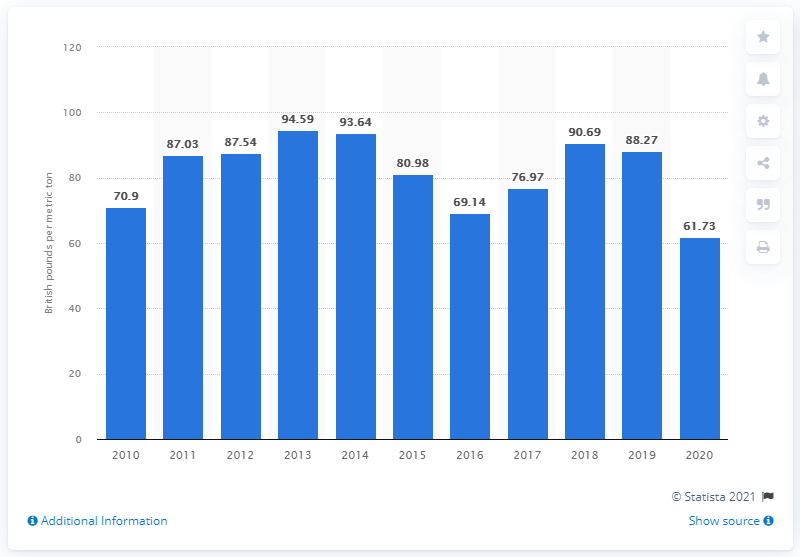List a handful of essential elements in this visual. In 2020, the average price of coal per metric ton in the UK was 61.73. 